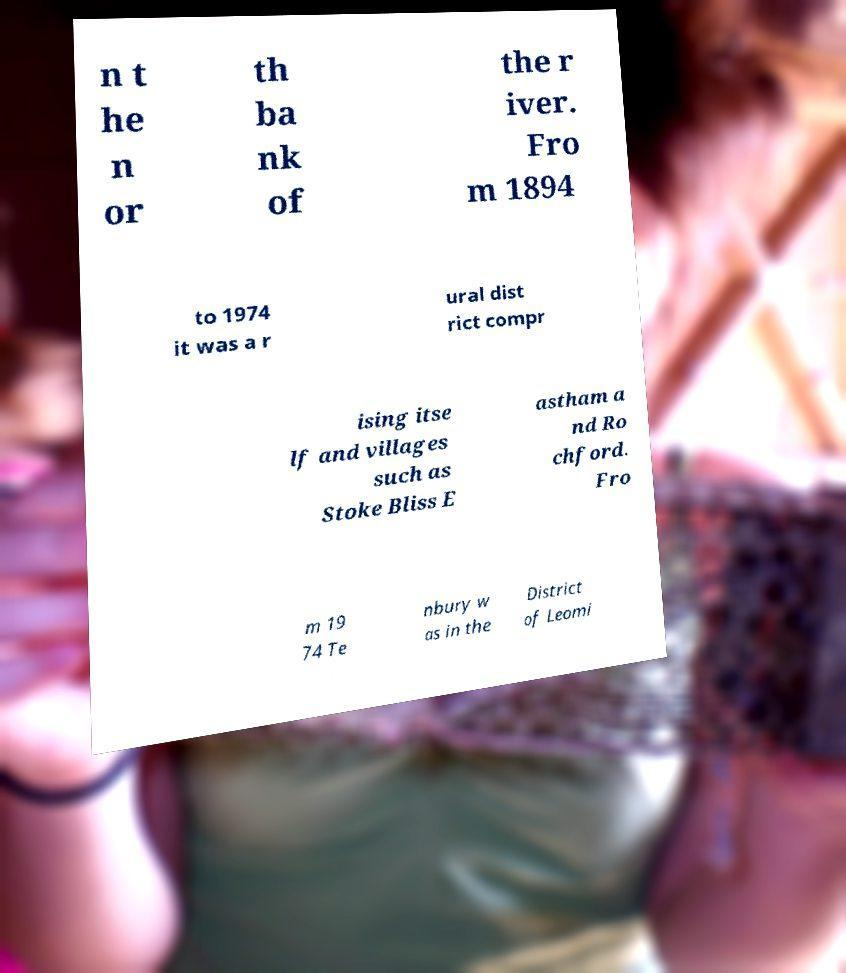What messages or text are displayed in this image? I need them in a readable, typed format. n t he n or th ba nk of the r iver. Fro m 1894 to 1974 it was a r ural dist rict compr ising itse lf and villages such as Stoke Bliss E astham a nd Ro chford. Fro m 19 74 Te nbury w as in the District of Leomi 